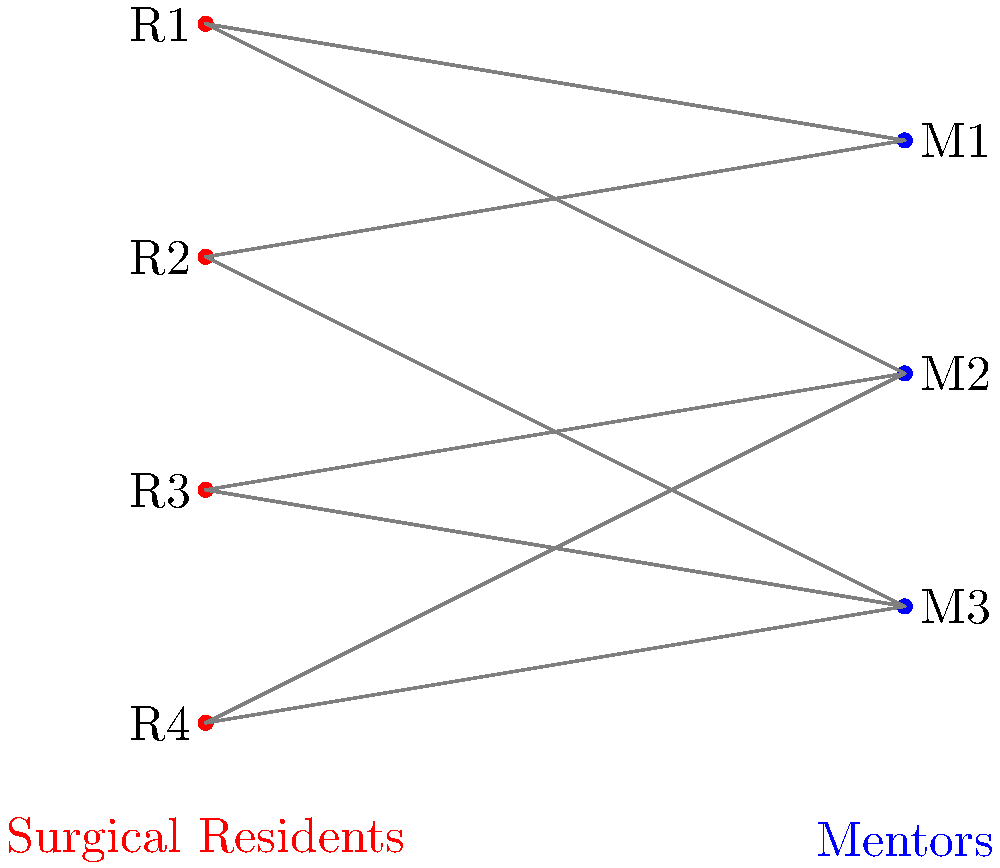In a surgical residency program, we need to match residents to mentors. The bipartite graph above represents the compatibility between 4 residents (R1, R2, R3, R4) and 3 mentors (M1, M2, M3). Each edge indicates a potential match. What is the maximum number of residents that can be matched to mentors, and which specific matching achieves this maximum? To solve this problem, we'll use the concept of maximum matching in bipartite graphs. Let's approach this step-by-step:

1) First, let's list all the possible connections:
   R1 - M1, M2
   R2 - M1, M3
   R3 - M2, M3
   R4 - M2, M3

2) We can use the Hungarian algorithm or the Ford-Fulkerson algorithm to find the maximum matching, but for this small graph, we can solve it by inspection.

3) Let's start matching:
   - Match R1 to M1
   - R2 can't match with M1 now, so match R2 to M3
   - R3 can only match with M2 now
   - R4 has no available mentors left

4) This gives us a maximum matching of 3 pairs:
   (R1, M1), (R2, M3), (R3, M2)

5) We can verify that this is indeed the maximum:
   - We can't match all 4 residents because there are only 3 mentors.
   - We've matched all 3 mentors, so this is the best we can do.

6) The maximum number of residents that can be matched is therefore 3.

7) The specific matching that achieves this maximum is:
   R1 - M1
   R2 - M3
   R3 - M2
Answer: 3; R1-M1, R2-M3, R3-M2 